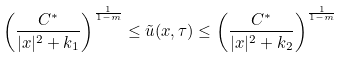Convert formula to latex. <formula><loc_0><loc_0><loc_500><loc_500>\left ( \frac { C ^ { * } } { | x | ^ { 2 } + k _ { 1 } } \right ) ^ { \frac { 1 } { 1 - m } } \leq \tilde { u } ( x , \tau ) \leq \left ( \frac { C ^ { * } } { | x | ^ { 2 } + k _ { 2 } } \right ) ^ { \frac { 1 } { 1 - m } }</formula> 